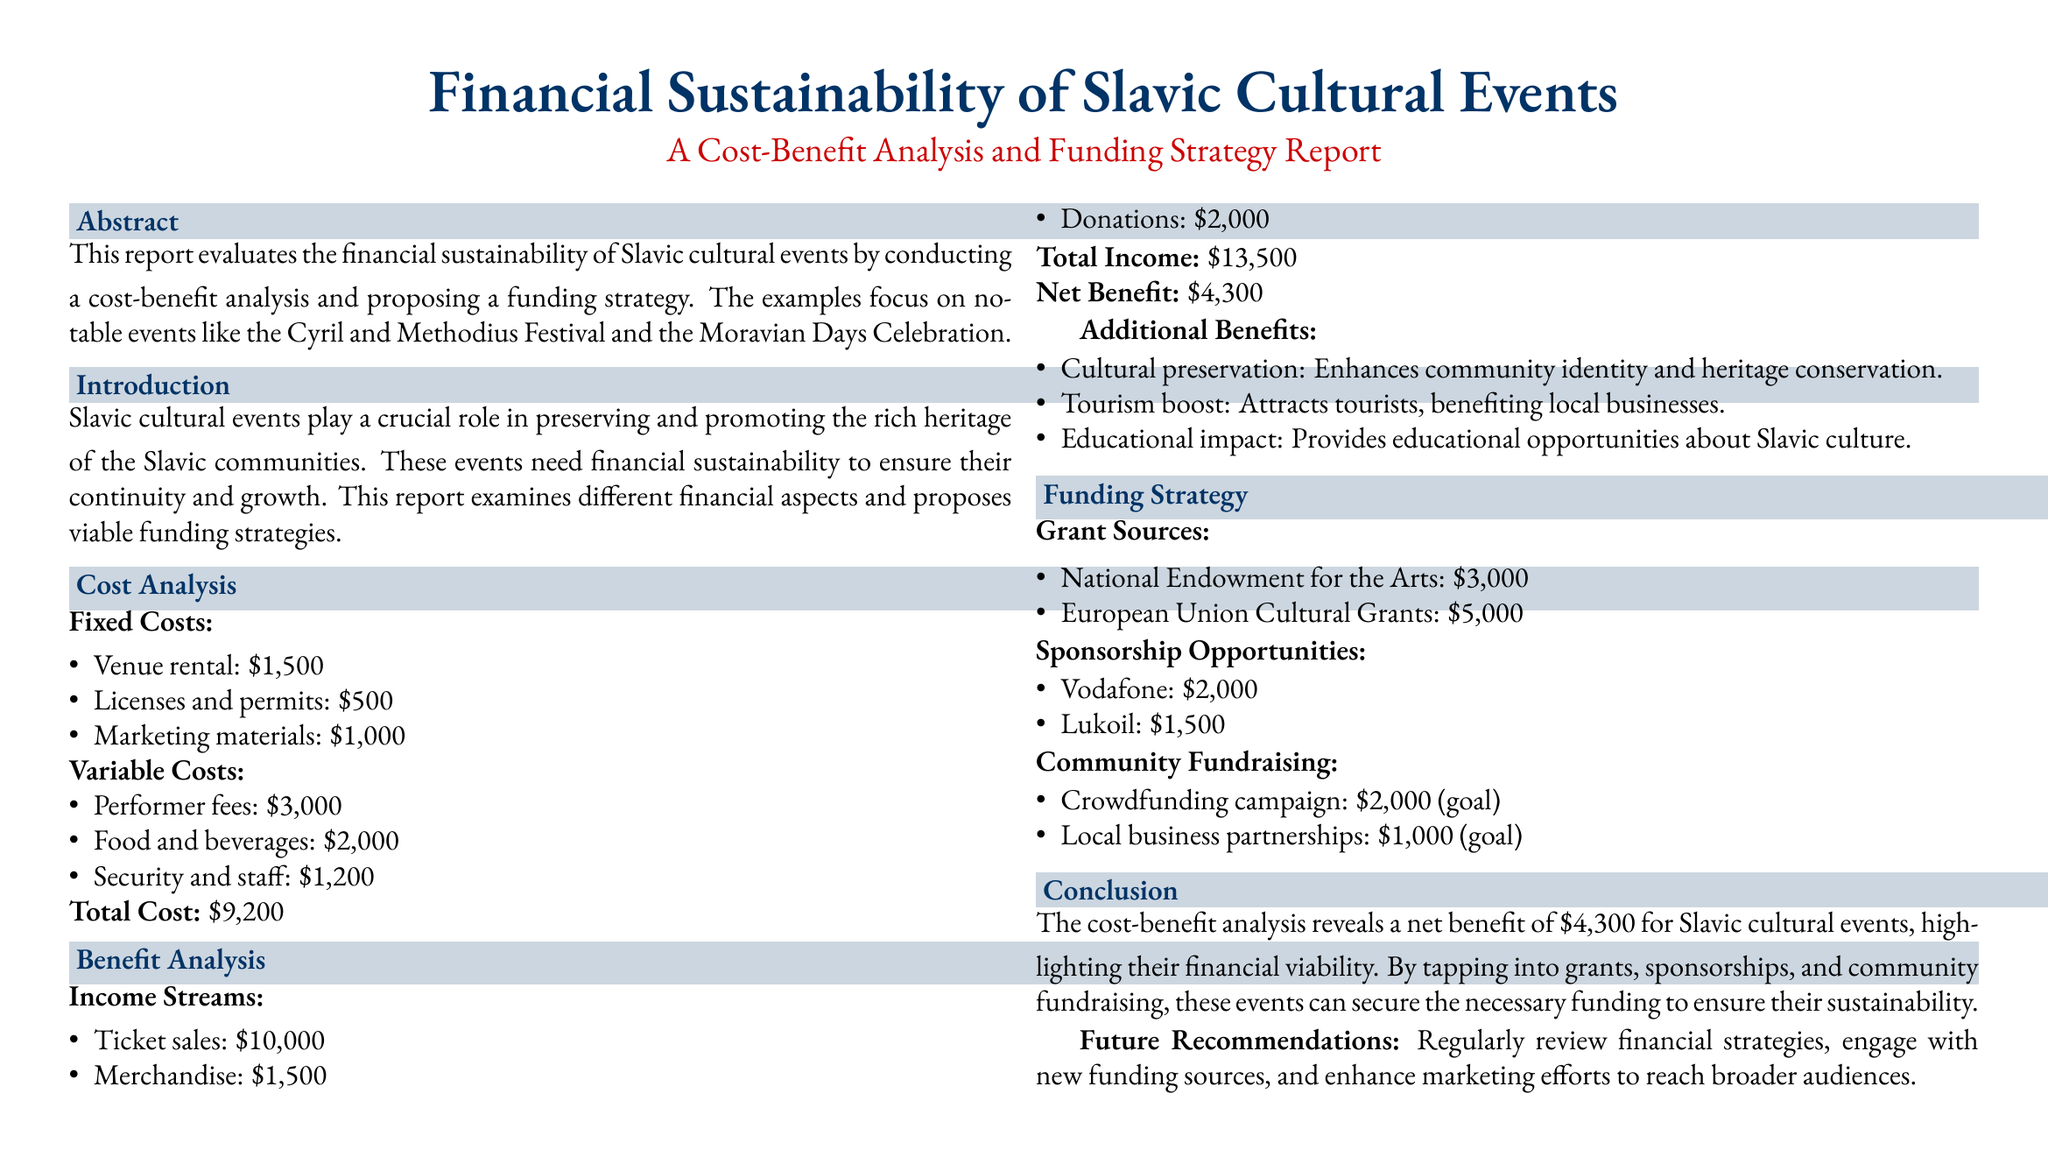What is the total cost of the event? The total cost is listed under the cost analysis section, summing the fixed and variable costs provided.
Answer: $9,200 What is the net benefit from the event? The net benefit is calculated by subtracting the total cost from the total income in the benefit analysis section.
Answer: $4,300 What are the ticket sales from the event? Ticket sales are one of the income streams detailed in the benefit analysis section.
Answer: $10,000 Which festival is mentioned in the report? The report specifically highlights the Cyril and Methodius Festival and the Moravian Days Celebration in the abstract.
Answer: Cyril and Methodius Festival What is one of the recommended funding sources? The funding strategy section lists various grant sources available to the events, which includes grants mentioned in the document.
Answer: National Endowment for the Arts What is the goal for the crowdfunding campaign? The document specifies the goal for the crowdfunding campaign in the community fundraising section.
Answer: $2,000 Which company is listed as a sponsor opportunity? The funding strategy section includes sponsorship opportunities, one of which is specifically identified.
Answer: Vodafone What is listed as an additional benefit of the events? Additional benefits are provided in the benefit analysis section; one such benefit focuses on cultural aspects.
Answer: Cultural preservation What is the total income from the event? The total income is derived from the sum of all income sources in the benefit analysis section.
Answer: $13,500 